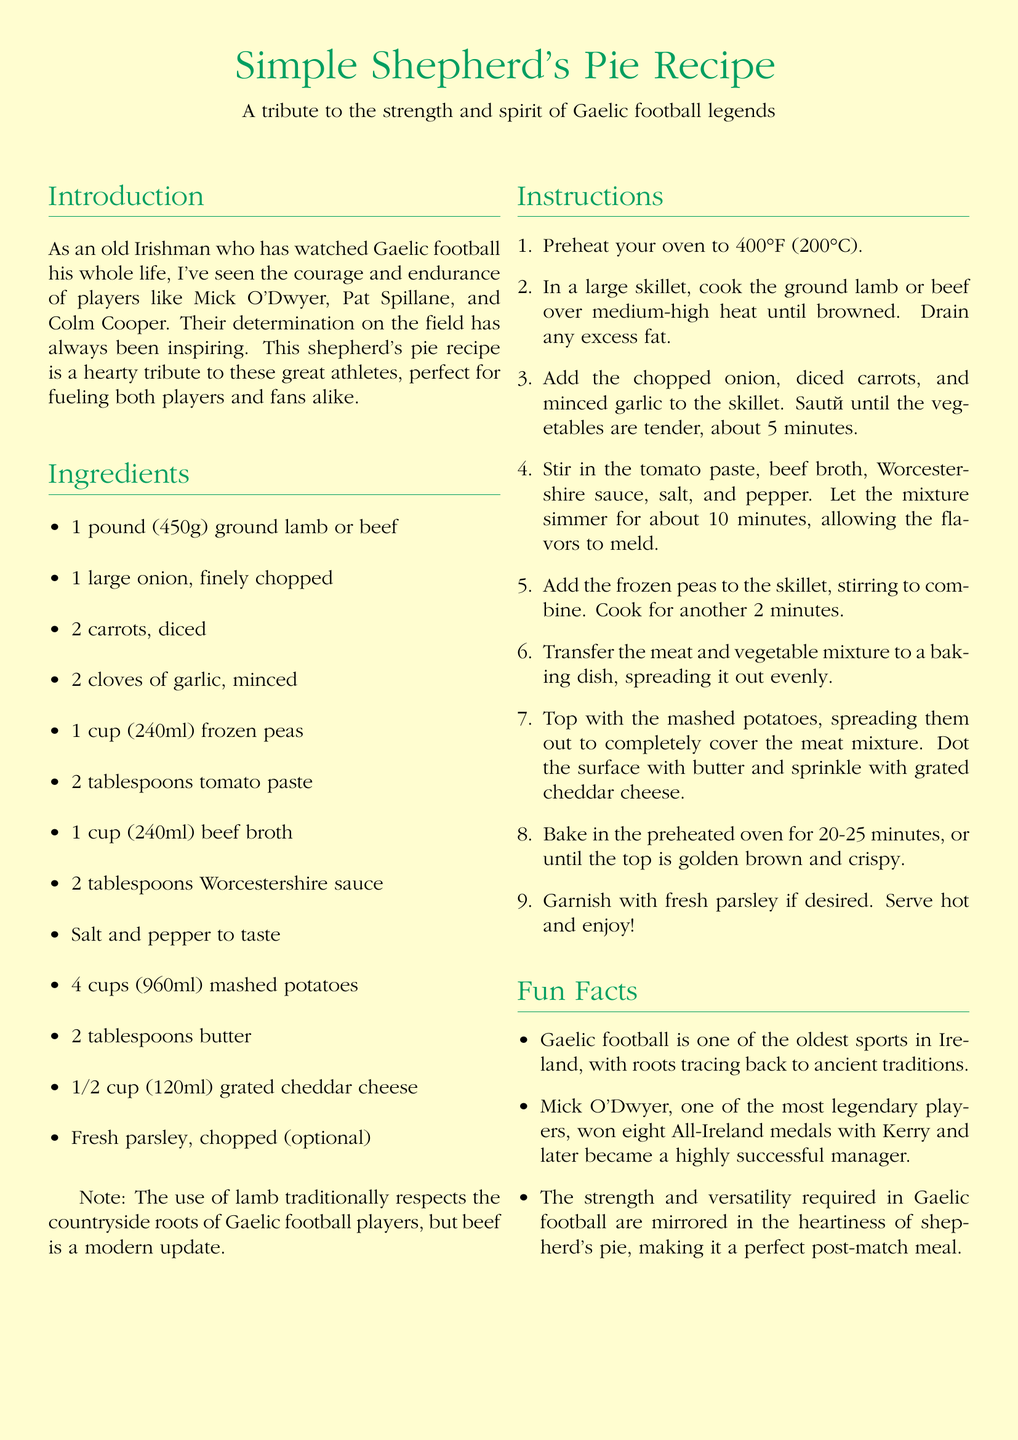what is the cooking temperature for the shepherd's pie? The shepherd's pie should be baked at 400°F (200°C) as stated in the instructions section.
Answer: 400°F (200°C) who is mentioned as a legendary player in the introduction? Mick O'Dwyer is highlighted as one of the legendary players in the introduction.
Answer: Mick O'Dwyer how many cups of mashed potatoes are needed for the recipe? The ingredients list specifies 4 cups (960ml) of mashed potatoes is required for the recipe.
Answer: 4 cups (960ml) what do the peas add to the shepherd's pie? The frozen peas are incorporated into the meat mixture and add color and flavor as they are stirred in during the cooking process, enhancing the overall dish.
Answer: Color and flavor how long should the shepherd's pie be baked? The recipe indicates that the pie should be baked for 20-25 minutes until the top is golden brown and crispy.
Answer: 20-25 minutes what type of cheese is used in the recipe? The recipe mentions that grated cheddar cheese is sprinkled on top before baking.
Answer: Cheddar cheese which two ingredients can be used instead of lamb according to the note? The note states that while lamb is traditional, beef can be used as a modern update in the shepherd's pie.
Answer: Beef what is the purpose of the fun facts section? The fun facts provide additional context and interesting tidbits related to Gaelic football and its connection to the dish.
Answer: Context and interest which player won eight All-Ireland medals? Mick O'Dwyer is noted for winning eight All-Ireland medals with Kerry in the fun facts section.
Answer: Mick O'Dwyer 